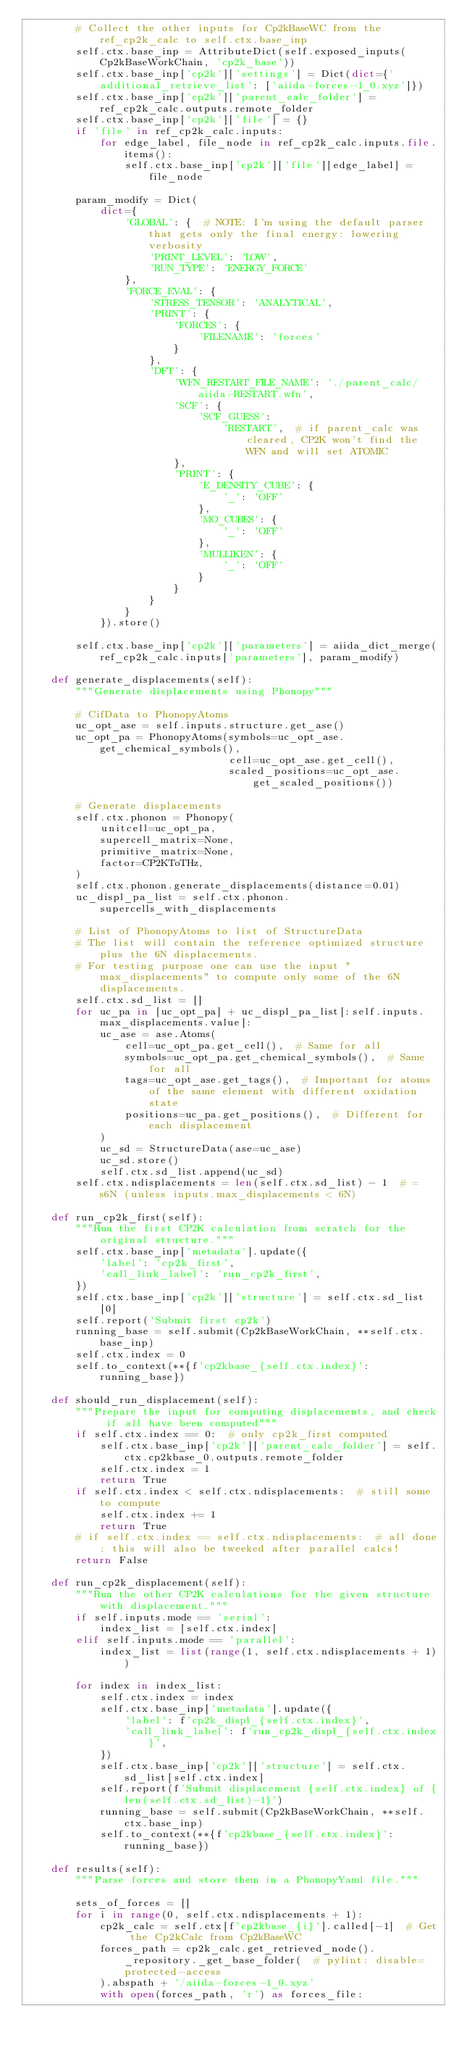Convert code to text. <code><loc_0><loc_0><loc_500><loc_500><_Python_>        # Collect the other inputs for Cp2kBaseWC from the ref_cp2k_calc to self.ctx.base_inp
        self.ctx.base_inp = AttributeDict(self.exposed_inputs(Cp2kBaseWorkChain, 'cp2k_base'))
        self.ctx.base_inp['cp2k']['settings'] = Dict(dict={'additional_retrieve_list': ['aiida-forces-1_0.xyz']})
        self.ctx.base_inp['cp2k']['parent_calc_folder'] = ref_cp2k_calc.outputs.remote_folder
        self.ctx.base_inp['cp2k']['file'] = {}
        if 'file' in ref_cp2k_calc.inputs:
            for edge_label, file_node in ref_cp2k_calc.inputs.file.items():
                self.ctx.base_inp['cp2k']['file'][edge_label] = file_node

        param_modify = Dict(
            dict={
                'GLOBAL': {  # NOTE: I'm using the default parser that gets only the final energy: lowering verbosity
                    'PRINT_LEVEL': 'LOW',
                    'RUN_TYPE': 'ENERGY_FORCE'
                },
                'FORCE_EVAL': {
                    'STRESS_TENSOR': 'ANALYTICAL',
                    'PRINT': {
                        'FORCES': {
                            'FILENAME': 'forces'
                        }
                    },
                    'DFT': {
                        'WFN_RESTART_FILE_NAME': './parent_calc/aiida-RESTART.wfn',
                        'SCF': {
                            'SCF_GUESS':
                                'RESTART',  # if parent_calc was cleared, CP2K won't find the WFN and will set ATOMIC
                        },
                        'PRINT': {
                            'E_DENSITY_CUBE': {
                                '_': 'OFF'
                            },
                            'MO_CUBES': {
                                '_': 'OFF'
                            },
                            'MULLIKEN': {
                                '_': 'OFF'
                            }
                        }
                    }
                }
            }).store()

        self.ctx.base_inp['cp2k']['parameters'] = aiida_dict_merge(ref_cp2k_calc.inputs['parameters'], param_modify)

    def generate_displacements(self):
        """Generate displacements using Phonopy"""

        # CifData to PhonopyAtoms
        uc_opt_ase = self.inputs.structure.get_ase()
        uc_opt_pa = PhonopyAtoms(symbols=uc_opt_ase.get_chemical_symbols(),
                                 cell=uc_opt_ase.get_cell(),
                                 scaled_positions=uc_opt_ase.get_scaled_positions())

        # Generate displacements
        self.ctx.phonon = Phonopy(
            unitcell=uc_opt_pa,
            supercell_matrix=None,
            primitive_matrix=None,
            factor=CP2KToTHz,
        )
        self.ctx.phonon.generate_displacements(distance=0.01)
        uc_displ_pa_list = self.ctx.phonon.supercells_with_displacements

        # List of PhonopyAtoms to list of StructureData
        # The list will contain the reference optimized structure plus the 6N displacements.
        # For testing purpose one can use the input "max_displacements" to compute only some of the 6N displacements.
        self.ctx.sd_list = []
        for uc_pa in [uc_opt_pa] + uc_displ_pa_list[:self.inputs.max_displacements.value]:
            uc_ase = ase.Atoms(
                cell=uc_opt_pa.get_cell(),  # Same for all
                symbols=uc_opt_pa.get_chemical_symbols(),  # Same for all
                tags=uc_opt_ase.get_tags(),  # Important for atoms of the same element with different oxidation state
                positions=uc_pa.get_positions(),  # Different for each displacement
            )
            uc_sd = StructureData(ase=uc_ase)
            uc_sd.store()
            self.ctx.sd_list.append(uc_sd)
        self.ctx.ndisplacements = len(self.ctx.sd_list) - 1  # = s6N (unless inputs.max_displacements < 6N)

    def run_cp2k_first(self):
        """Run the first CP2K calculation from scratch for the original structure."""
        self.ctx.base_inp['metadata'].update({
            'label': 'cp2k_first',
            'call_link_label': 'run_cp2k_first',
        })
        self.ctx.base_inp['cp2k']['structure'] = self.ctx.sd_list[0]
        self.report('Submit first cp2k')
        running_base = self.submit(Cp2kBaseWorkChain, **self.ctx.base_inp)
        self.ctx.index = 0
        self.to_context(**{f'cp2kbase_{self.ctx.index}': running_base})

    def should_run_displacement(self):
        """Prepare the input for computing displacements, and check if all have been computed"""
        if self.ctx.index == 0:  # only cp2k_first computed
            self.ctx.base_inp['cp2k']['parent_calc_folder'] = self.ctx.cp2kbase_0.outputs.remote_folder
            self.ctx.index = 1
            return True
        if self.ctx.index < self.ctx.ndisplacements:  # still some to compute
            self.ctx.index += 1
            return True
        # if self.ctx.index == self.ctx.ndisplacements:  # all done: this will also be tweeked after parallel calcs!
        return False

    def run_cp2k_displacement(self):
        """Run the other CP2K calculations for the given structure with displacement."""
        if self.inputs.mode == 'serial':
            index_list = [self.ctx.index]
        elif self.inputs.mode == 'parallel':
            index_list = list(range(1, self.ctx.ndisplacements + 1))

        for index in index_list:
            self.ctx.index = index
            self.ctx.base_inp['metadata'].update({
                'label': f'cp2k_displ_{self.ctx.index}',
                'call_link_label': f'run_cp2k_displ_{self.ctx.index}',
            })
            self.ctx.base_inp['cp2k']['structure'] = self.ctx.sd_list[self.ctx.index]
            self.report(f'Submit displacement {self.ctx.index} of {len(self.ctx.sd_list)-1}')
            running_base = self.submit(Cp2kBaseWorkChain, **self.ctx.base_inp)
            self.to_context(**{f'cp2kbase_{self.ctx.index}': running_base})

    def results(self):
        """Parse forces and store them in a PhonopyYaml file."""

        sets_of_forces = []
        for i in range(0, self.ctx.ndisplacements + 1):
            cp2k_calc = self.ctx[f'cp2kbase_{i}'].called[-1]  # Get the Cp2kCalc from Cp2kBaseWC
            forces_path = cp2k_calc.get_retrieved_node()._repository._get_base_folder(  # pylint: disable=protected-access
            ).abspath + '/aiida-forces-1_0.xyz'
            with open(forces_path, 'r') as forces_file:</code> 